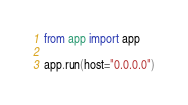<code> <loc_0><loc_0><loc_500><loc_500><_Python_>from app import app

app.run(host="0.0.0.0")
</code> 